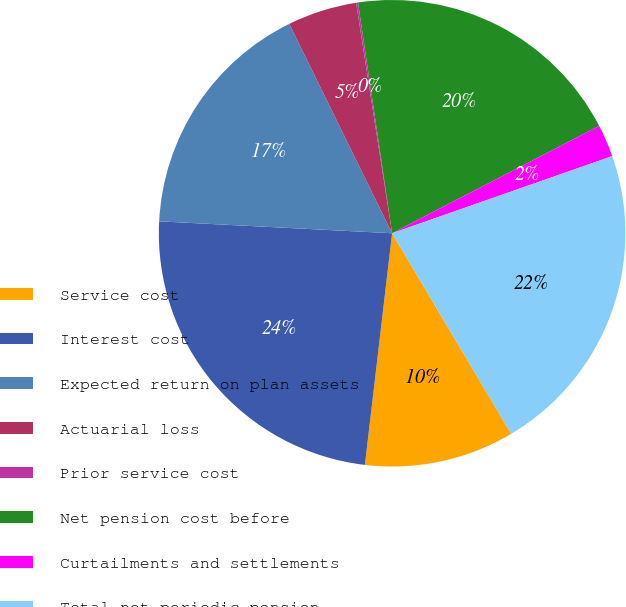Convert chart. <chart><loc_0><loc_0><loc_500><loc_500><pie_chart><fcel>Service cost<fcel>Interest cost<fcel>Expected return on plan assets<fcel>Actuarial loss<fcel>Prior service cost<fcel>Net pension cost before<fcel>Curtailments and settlements<fcel>Total net periodic pension<nl><fcel>10.39%<fcel>23.95%<fcel>16.92%<fcel>4.8%<fcel>0.13%<fcel>19.72%<fcel>2.25%<fcel>21.83%<nl></chart> 